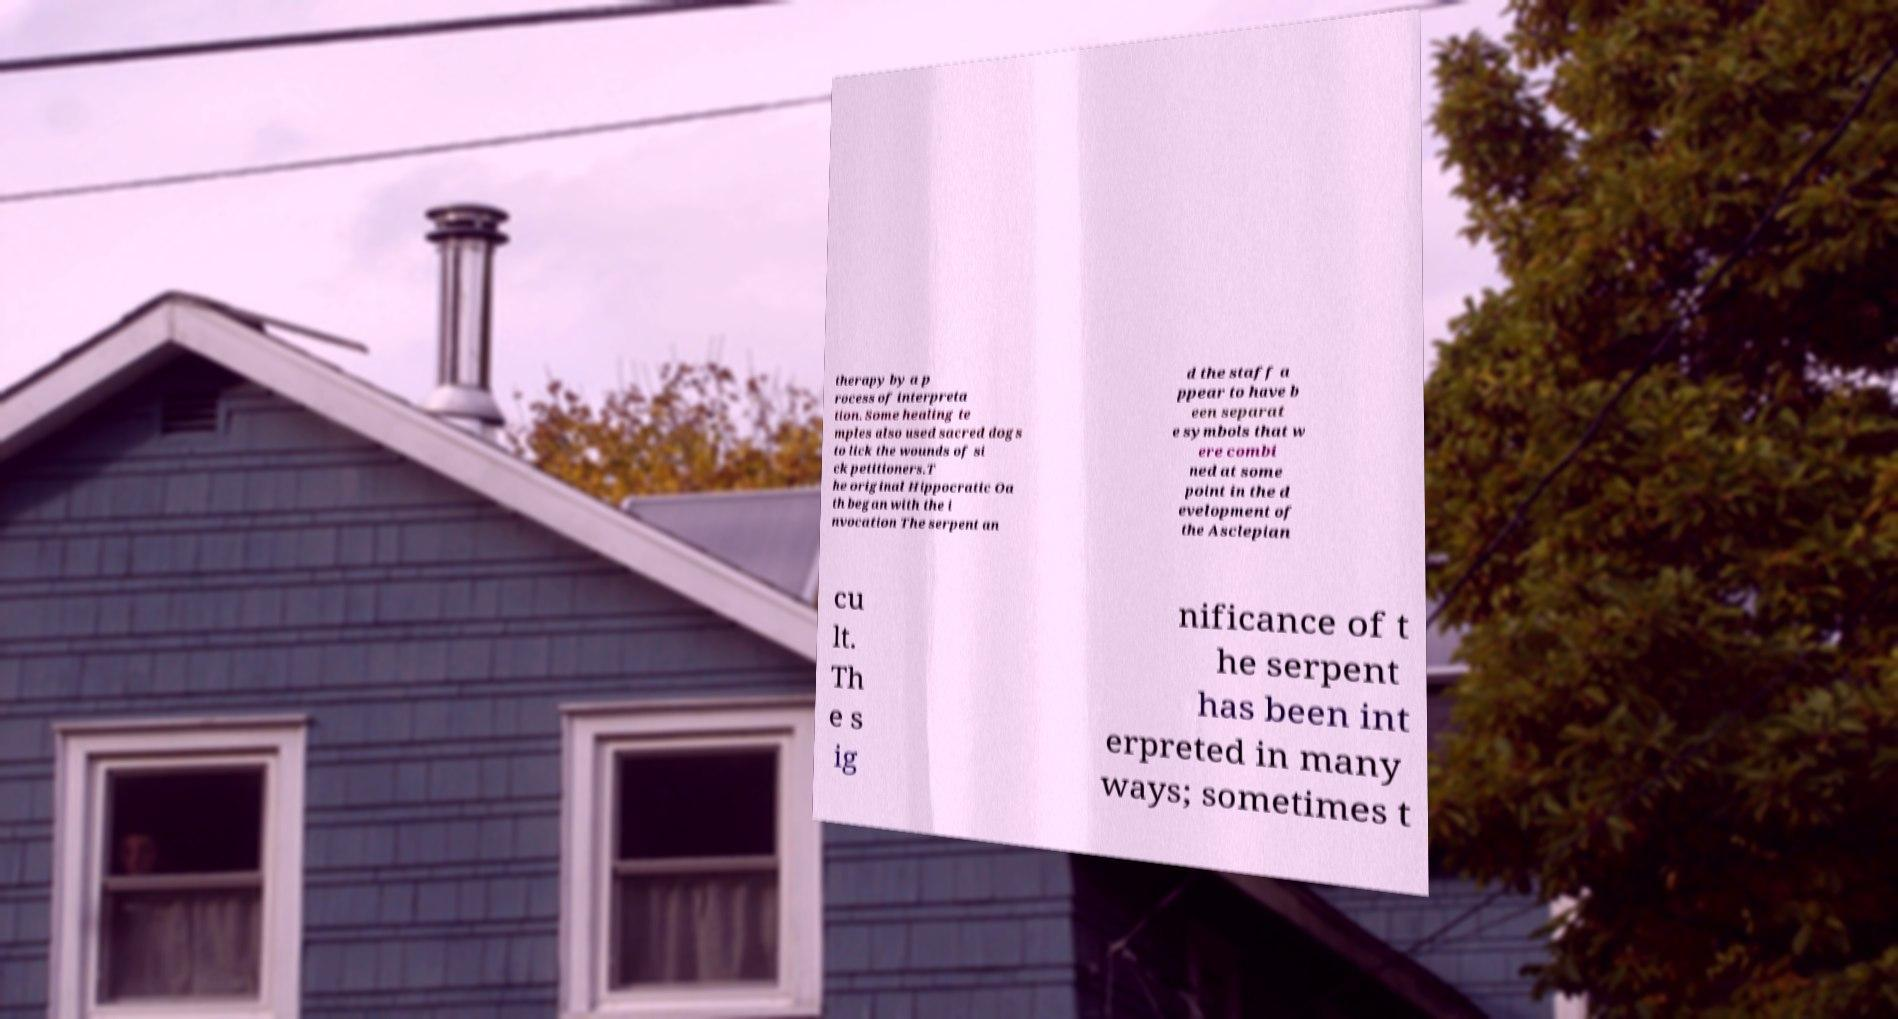Could you extract and type out the text from this image? therapy by a p rocess of interpreta tion. Some healing te mples also used sacred dogs to lick the wounds of si ck petitioners.T he original Hippocratic Oa th began with the i nvocation The serpent an d the staff a ppear to have b een separat e symbols that w ere combi ned at some point in the d evelopment of the Asclepian cu lt. Th e s ig nificance of t he serpent has been int erpreted in many ways; sometimes t 